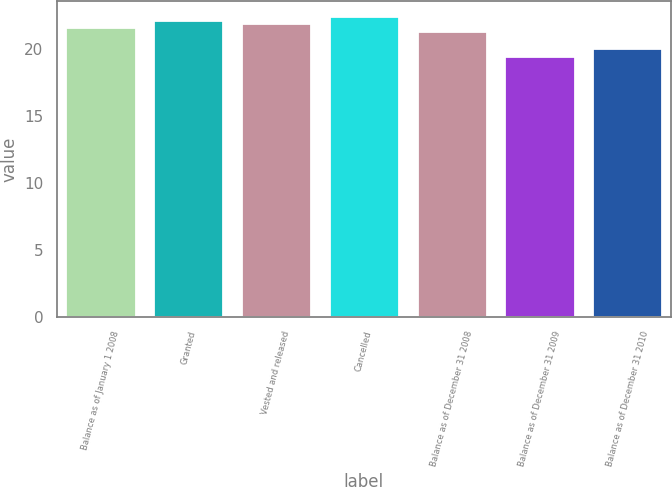Convert chart. <chart><loc_0><loc_0><loc_500><loc_500><bar_chart><fcel>Balance as of January 1 2008<fcel>Granted<fcel>Vested and released<fcel>Cancelled<fcel>Balance as of December 31 2008<fcel>Balance as of December 31 2009<fcel>Balance as of December 31 2010<nl><fcel>21.68<fcel>22.22<fcel>21.95<fcel>22.49<fcel>21.41<fcel>19.5<fcel>20.12<nl></chart> 